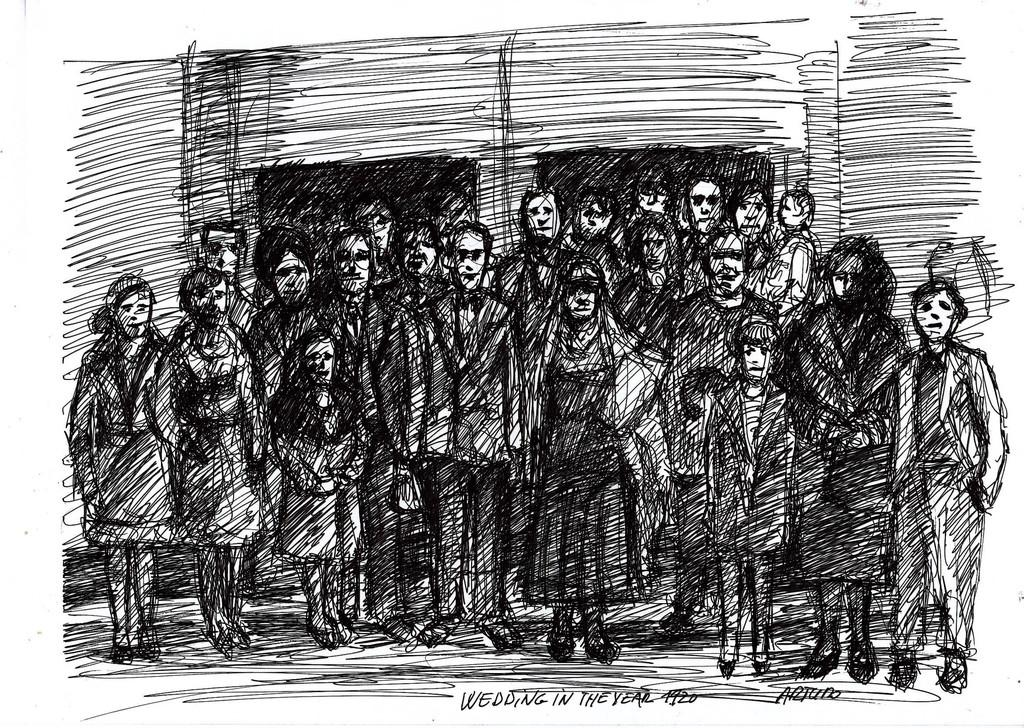What is the main subject of the image? There is an art piece in the image. Can you describe any additional details about the art piece? Unfortunately, the provided facts do not offer any additional details about the art piece. What is written or displayed at the bottom of the image? There is text at the bottom of the image. What type of flower is depicted in the art piece, and what is its current condition? There is no flower depicted in the art piece, as the image only features an art piece and text at the bottom. How did the art piece catch on fire, and what is the extent of the burn damage? There is no indication of fire or burn damage in the image, as it only features an art piece and text at the bottom. 